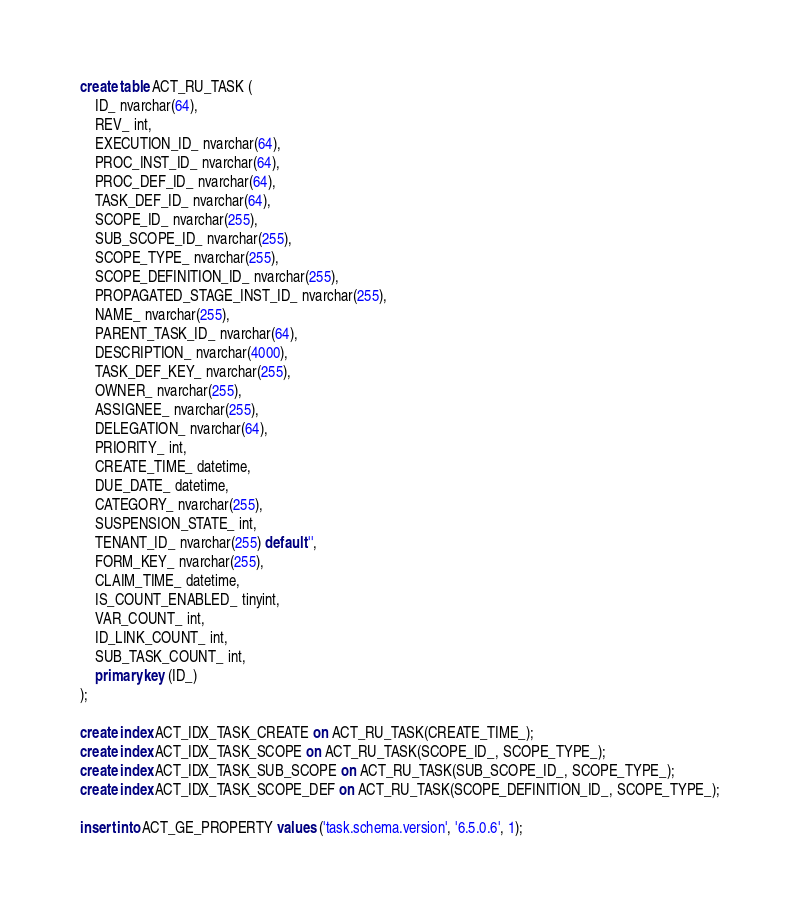Convert code to text. <code><loc_0><loc_0><loc_500><loc_500><_SQL_>create table ACT_RU_TASK (
    ID_ nvarchar(64),
    REV_ int,
    EXECUTION_ID_ nvarchar(64),
    PROC_INST_ID_ nvarchar(64),
    PROC_DEF_ID_ nvarchar(64),
    TASK_DEF_ID_ nvarchar(64),
    SCOPE_ID_ nvarchar(255),
    SUB_SCOPE_ID_ nvarchar(255),
    SCOPE_TYPE_ nvarchar(255),
    SCOPE_DEFINITION_ID_ nvarchar(255),
    PROPAGATED_STAGE_INST_ID_ nvarchar(255),
    NAME_ nvarchar(255),
    PARENT_TASK_ID_ nvarchar(64),
    DESCRIPTION_ nvarchar(4000),
    TASK_DEF_KEY_ nvarchar(255),
    OWNER_ nvarchar(255),
    ASSIGNEE_ nvarchar(255),
    DELEGATION_ nvarchar(64),
    PRIORITY_ int,
    CREATE_TIME_ datetime,
    DUE_DATE_ datetime,
    CATEGORY_ nvarchar(255),
    SUSPENSION_STATE_ int,
    TENANT_ID_ nvarchar(255) default '',
    FORM_KEY_ nvarchar(255),
    CLAIM_TIME_ datetime,
    IS_COUNT_ENABLED_ tinyint,
    VAR_COUNT_ int, 
    ID_LINK_COUNT_ int,
    SUB_TASK_COUNT_ int,
    primary key (ID_)
);

create index ACT_IDX_TASK_CREATE on ACT_RU_TASK(CREATE_TIME_);
create index ACT_IDX_TASK_SCOPE on ACT_RU_TASK(SCOPE_ID_, SCOPE_TYPE_);
create index ACT_IDX_TASK_SUB_SCOPE on ACT_RU_TASK(SUB_SCOPE_ID_, SCOPE_TYPE_);
create index ACT_IDX_TASK_SCOPE_DEF on ACT_RU_TASK(SCOPE_DEFINITION_ID_, SCOPE_TYPE_);

insert into ACT_GE_PROPERTY values ('task.schema.version', '6.5.0.6', 1);</code> 